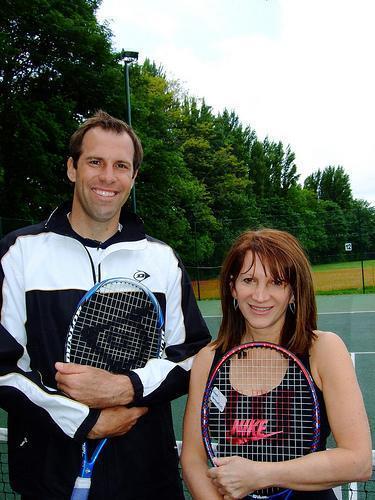How many tennis rackets are there?
Give a very brief answer. 2. 